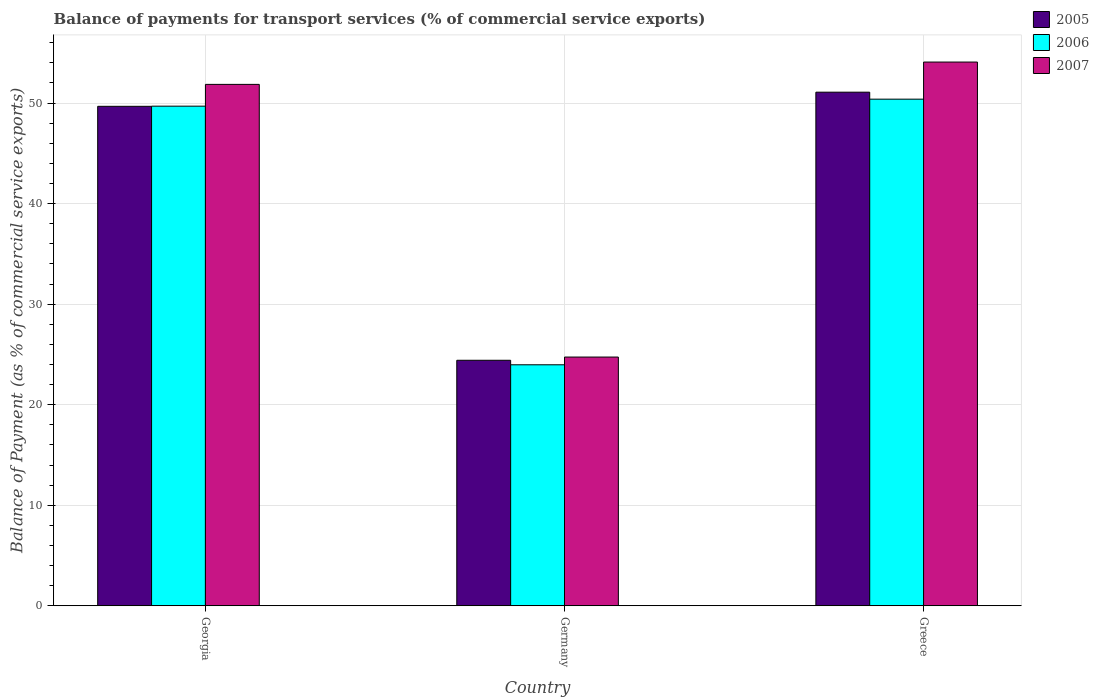Are the number of bars per tick equal to the number of legend labels?
Provide a succinct answer. Yes. Are the number of bars on each tick of the X-axis equal?
Give a very brief answer. Yes. What is the label of the 1st group of bars from the left?
Your answer should be very brief. Georgia. What is the balance of payments for transport services in 2005 in Greece?
Provide a short and direct response. 51.08. Across all countries, what is the maximum balance of payments for transport services in 2006?
Provide a short and direct response. 50.38. Across all countries, what is the minimum balance of payments for transport services in 2007?
Keep it short and to the point. 24.74. In which country was the balance of payments for transport services in 2005 maximum?
Give a very brief answer. Greece. What is the total balance of payments for transport services in 2007 in the graph?
Ensure brevity in your answer.  130.66. What is the difference between the balance of payments for transport services in 2005 in Georgia and that in Greece?
Provide a short and direct response. -1.41. What is the difference between the balance of payments for transport services in 2007 in Greece and the balance of payments for transport services in 2006 in Georgia?
Your response must be concise. 4.39. What is the average balance of payments for transport services in 2007 per country?
Offer a very short reply. 43.55. What is the difference between the balance of payments for transport services of/in 2006 and balance of payments for transport services of/in 2007 in Greece?
Provide a succinct answer. -3.69. What is the ratio of the balance of payments for transport services in 2006 in Germany to that in Greece?
Offer a terse response. 0.48. What is the difference between the highest and the second highest balance of payments for transport services in 2006?
Give a very brief answer. -0.7. What is the difference between the highest and the lowest balance of payments for transport services in 2007?
Offer a terse response. 29.34. Is the sum of the balance of payments for transport services in 2007 in Georgia and Greece greater than the maximum balance of payments for transport services in 2005 across all countries?
Provide a short and direct response. Yes. What does the 1st bar from the left in Germany represents?
Provide a succinct answer. 2005. How many bars are there?
Give a very brief answer. 9. Are all the bars in the graph horizontal?
Ensure brevity in your answer.  No. How many countries are there in the graph?
Your answer should be compact. 3. What is the difference between two consecutive major ticks on the Y-axis?
Your answer should be very brief. 10. Are the values on the major ticks of Y-axis written in scientific E-notation?
Make the answer very short. No. How many legend labels are there?
Your answer should be compact. 3. What is the title of the graph?
Your response must be concise. Balance of payments for transport services (% of commercial service exports). Does "1967" appear as one of the legend labels in the graph?
Your answer should be compact. No. What is the label or title of the Y-axis?
Provide a short and direct response. Balance of Payment (as % of commercial service exports). What is the Balance of Payment (as % of commercial service exports) of 2005 in Georgia?
Your answer should be very brief. 49.67. What is the Balance of Payment (as % of commercial service exports) in 2006 in Georgia?
Offer a terse response. 49.69. What is the Balance of Payment (as % of commercial service exports) of 2007 in Georgia?
Offer a very short reply. 51.85. What is the Balance of Payment (as % of commercial service exports) of 2005 in Germany?
Your answer should be very brief. 24.42. What is the Balance of Payment (as % of commercial service exports) in 2006 in Germany?
Keep it short and to the point. 23.97. What is the Balance of Payment (as % of commercial service exports) in 2007 in Germany?
Keep it short and to the point. 24.74. What is the Balance of Payment (as % of commercial service exports) in 2005 in Greece?
Offer a terse response. 51.08. What is the Balance of Payment (as % of commercial service exports) in 2006 in Greece?
Keep it short and to the point. 50.38. What is the Balance of Payment (as % of commercial service exports) of 2007 in Greece?
Ensure brevity in your answer.  54.07. Across all countries, what is the maximum Balance of Payment (as % of commercial service exports) of 2005?
Offer a terse response. 51.08. Across all countries, what is the maximum Balance of Payment (as % of commercial service exports) in 2006?
Provide a short and direct response. 50.38. Across all countries, what is the maximum Balance of Payment (as % of commercial service exports) of 2007?
Provide a succinct answer. 54.07. Across all countries, what is the minimum Balance of Payment (as % of commercial service exports) of 2005?
Provide a succinct answer. 24.42. Across all countries, what is the minimum Balance of Payment (as % of commercial service exports) of 2006?
Your response must be concise. 23.97. Across all countries, what is the minimum Balance of Payment (as % of commercial service exports) of 2007?
Give a very brief answer. 24.74. What is the total Balance of Payment (as % of commercial service exports) of 2005 in the graph?
Provide a short and direct response. 125.16. What is the total Balance of Payment (as % of commercial service exports) of 2006 in the graph?
Provide a succinct answer. 124.03. What is the total Balance of Payment (as % of commercial service exports) of 2007 in the graph?
Your answer should be compact. 130.66. What is the difference between the Balance of Payment (as % of commercial service exports) of 2005 in Georgia and that in Germany?
Provide a short and direct response. 25.25. What is the difference between the Balance of Payment (as % of commercial service exports) in 2006 in Georgia and that in Germany?
Offer a terse response. 25.72. What is the difference between the Balance of Payment (as % of commercial service exports) of 2007 in Georgia and that in Germany?
Offer a very short reply. 27.12. What is the difference between the Balance of Payment (as % of commercial service exports) of 2005 in Georgia and that in Greece?
Offer a terse response. -1.41. What is the difference between the Balance of Payment (as % of commercial service exports) in 2006 in Georgia and that in Greece?
Your answer should be compact. -0.7. What is the difference between the Balance of Payment (as % of commercial service exports) of 2007 in Georgia and that in Greece?
Your answer should be very brief. -2.22. What is the difference between the Balance of Payment (as % of commercial service exports) in 2005 in Germany and that in Greece?
Offer a terse response. -26.66. What is the difference between the Balance of Payment (as % of commercial service exports) of 2006 in Germany and that in Greece?
Provide a succinct answer. -26.41. What is the difference between the Balance of Payment (as % of commercial service exports) in 2007 in Germany and that in Greece?
Provide a succinct answer. -29.34. What is the difference between the Balance of Payment (as % of commercial service exports) of 2005 in Georgia and the Balance of Payment (as % of commercial service exports) of 2006 in Germany?
Your answer should be very brief. 25.7. What is the difference between the Balance of Payment (as % of commercial service exports) of 2005 in Georgia and the Balance of Payment (as % of commercial service exports) of 2007 in Germany?
Provide a short and direct response. 24.93. What is the difference between the Balance of Payment (as % of commercial service exports) of 2006 in Georgia and the Balance of Payment (as % of commercial service exports) of 2007 in Germany?
Ensure brevity in your answer.  24.95. What is the difference between the Balance of Payment (as % of commercial service exports) of 2005 in Georgia and the Balance of Payment (as % of commercial service exports) of 2006 in Greece?
Provide a succinct answer. -0.71. What is the difference between the Balance of Payment (as % of commercial service exports) in 2005 in Georgia and the Balance of Payment (as % of commercial service exports) in 2007 in Greece?
Provide a succinct answer. -4.4. What is the difference between the Balance of Payment (as % of commercial service exports) of 2006 in Georgia and the Balance of Payment (as % of commercial service exports) of 2007 in Greece?
Provide a succinct answer. -4.39. What is the difference between the Balance of Payment (as % of commercial service exports) of 2005 in Germany and the Balance of Payment (as % of commercial service exports) of 2006 in Greece?
Offer a very short reply. -25.97. What is the difference between the Balance of Payment (as % of commercial service exports) of 2005 in Germany and the Balance of Payment (as % of commercial service exports) of 2007 in Greece?
Your answer should be very brief. -29.66. What is the difference between the Balance of Payment (as % of commercial service exports) in 2006 in Germany and the Balance of Payment (as % of commercial service exports) in 2007 in Greece?
Provide a short and direct response. -30.11. What is the average Balance of Payment (as % of commercial service exports) of 2005 per country?
Your answer should be compact. 41.72. What is the average Balance of Payment (as % of commercial service exports) in 2006 per country?
Provide a short and direct response. 41.34. What is the average Balance of Payment (as % of commercial service exports) of 2007 per country?
Ensure brevity in your answer.  43.55. What is the difference between the Balance of Payment (as % of commercial service exports) in 2005 and Balance of Payment (as % of commercial service exports) in 2006 in Georgia?
Your answer should be very brief. -0.02. What is the difference between the Balance of Payment (as % of commercial service exports) of 2005 and Balance of Payment (as % of commercial service exports) of 2007 in Georgia?
Offer a very short reply. -2.18. What is the difference between the Balance of Payment (as % of commercial service exports) in 2006 and Balance of Payment (as % of commercial service exports) in 2007 in Georgia?
Your answer should be compact. -2.17. What is the difference between the Balance of Payment (as % of commercial service exports) of 2005 and Balance of Payment (as % of commercial service exports) of 2006 in Germany?
Keep it short and to the point. 0.45. What is the difference between the Balance of Payment (as % of commercial service exports) of 2005 and Balance of Payment (as % of commercial service exports) of 2007 in Germany?
Give a very brief answer. -0.32. What is the difference between the Balance of Payment (as % of commercial service exports) of 2006 and Balance of Payment (as % of commercial service exports) of 2007 in Germany?
Provide a succinct answer. -0.77. What is the difference between the Balance of Payment (as % of commercial service exports) of 2005 and Balance of Payment (as % of commercial service exports) of 2006 in Greece?
Keep it short and to the point. 0.7. What is the difference between the Balance of Payment (as % of commercial service exports) in 2005 and Balance of Payment (as % of commercial service exports) in 2007 in Greece?
Offer a very short reply. -2.99. What is the difference between the Balance of Payment (as % of commercial service exports) in 2006 and Balance of Payment (as % of commercial service exports) in 2007 in Greece?
Offer a terse response. -3.69. What is the ratio of the Balance of Payment (as % of commercial service exports) of 2005 in Georgia to that in Germany?
Offer a very short reply. 2.03. What is the ratio of the Balance of Payment (as % of commercial service exports) of 2006 in Georgia to that in Germany?
Your response must be concise. 2.07. What is the ratio of the Balance of Payment (as % of commercial service exports) of 2007 in Georgia to that in Germany?
Give a very brief answer. 2.1. What is the ratio of the Balance of Payment (as % of commercial service exports) in 2005 in Georgia to that in Greece?
Your response must be concise. 0.97. What is the ratio of the Balance of Payment (as % of commercial service exports) of 2006 in Georgia to that in Greece?
Ensure brevity in your answer.  0.99. What is the ratio of the Balance of Payment (as % of commercial service exports) in 2005 in Germany to that in Greece?
Offer a terse response. 0.48. What is the ratio of the Balance of Payment (as % of commercial service exports) of 2006 in Germany to that in Greece?
Offer a very short reply. 0.48. What is the ratio of the Balance of Payment (as % of commercial service exports) of 2007 in Germany to that in Greece?
Your answer should be compact. 0.46. What is the difference between the highest and the second highest Balance of Payment (as % of commercial service exports) in 2005?
Keep it short and to the point. 1.41. What is the difference between the highest and the second highest Balance of Payment (as % of commercial service exports) in 2006?
Offer a terse response. 0.7. What is the difference between the highest and the second highest Balance of Payment (as % of commercial service exports) in 2007?
Keep it short and to the point. 2.22. What is the difference between the highest and the lowest Balance of Payment (as % of commercial service exports) of 2005?
Offer a very short reply. 26.66. What is the difference between the highest and the lowest Balance of Payment (as % of commercial service exports) of 2006?
Offer a very short reply. 26.41. What is the difference between the highest and the lowest Balance of Payment (as % of commercial service exports) in 2007?
Make the answer very short. 29.34. 